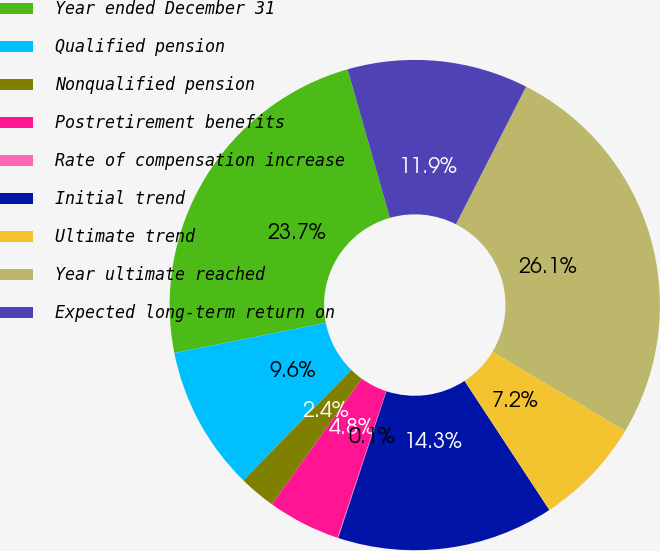Convert chart. <chart><loc_0><loc_0><loc_500><loc_500><pie_chart><fcel>Year ended December 31<fcel>Qualified pension<fcel>Nonqualified pension<fcel>Postretirement benefits<fcel>Rate of compensation increase<fcel>Initial trend<fcel>Ultimate trend<fcel>Year ultimate reached<fcel>Expected long-term return on<nl><fcel>23.71%<fcel>9.55%<fcel>2.42%<fcel>4.8%<fcel>0.05%<fcel>14.3%<fcel>7.17%<fcel>26.08%<fcel>11.92%<nl></chart> 